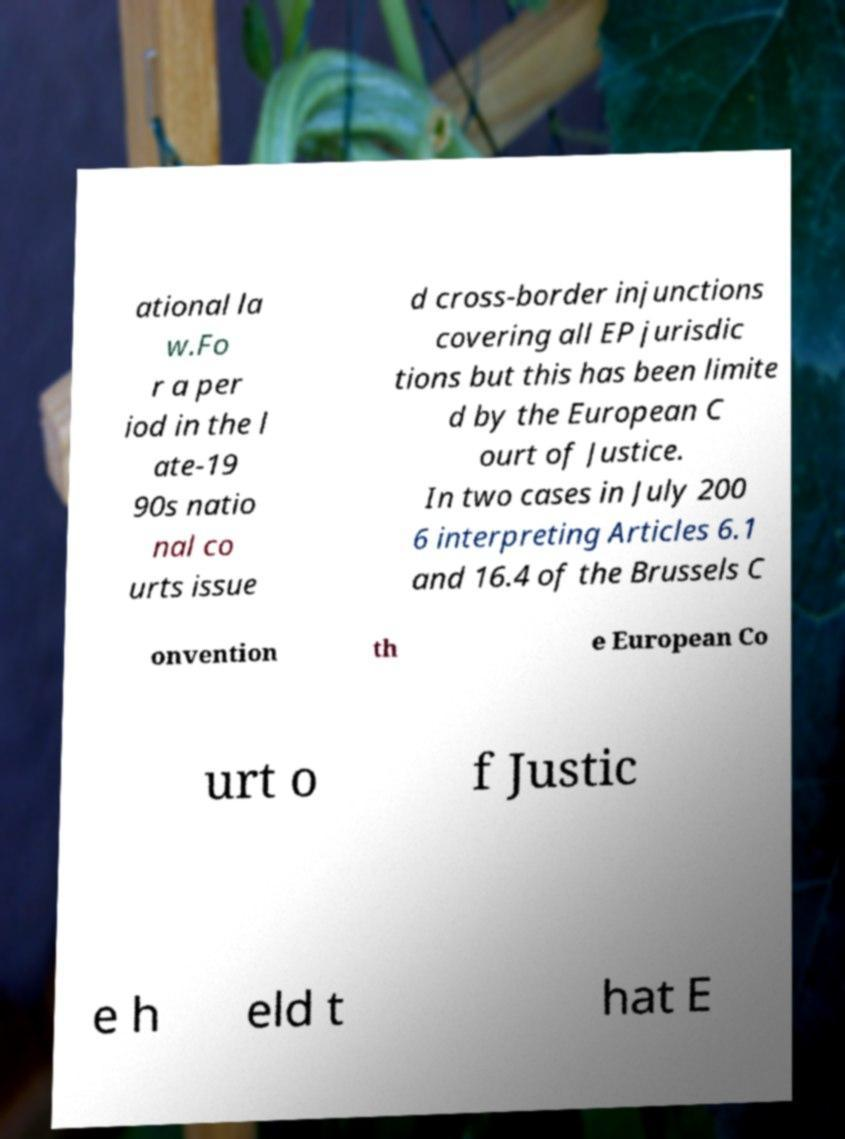Can you read and provide the text displayed in the image?This photo seems to have some interesting text. Can you extract and type it out for me? ational la w.Fo r a per iod in the l ate-19 90s natio nal co urts issue d cross-border injunctions covering all EP jurisdic tions but this has been limite d by the European C ourt of Justice. In two cases in July 200 6 interpreting Articles 6.1 and 16.4 of the Brussels C onvention th e European Co urt o f Justic e h eld t hat E 